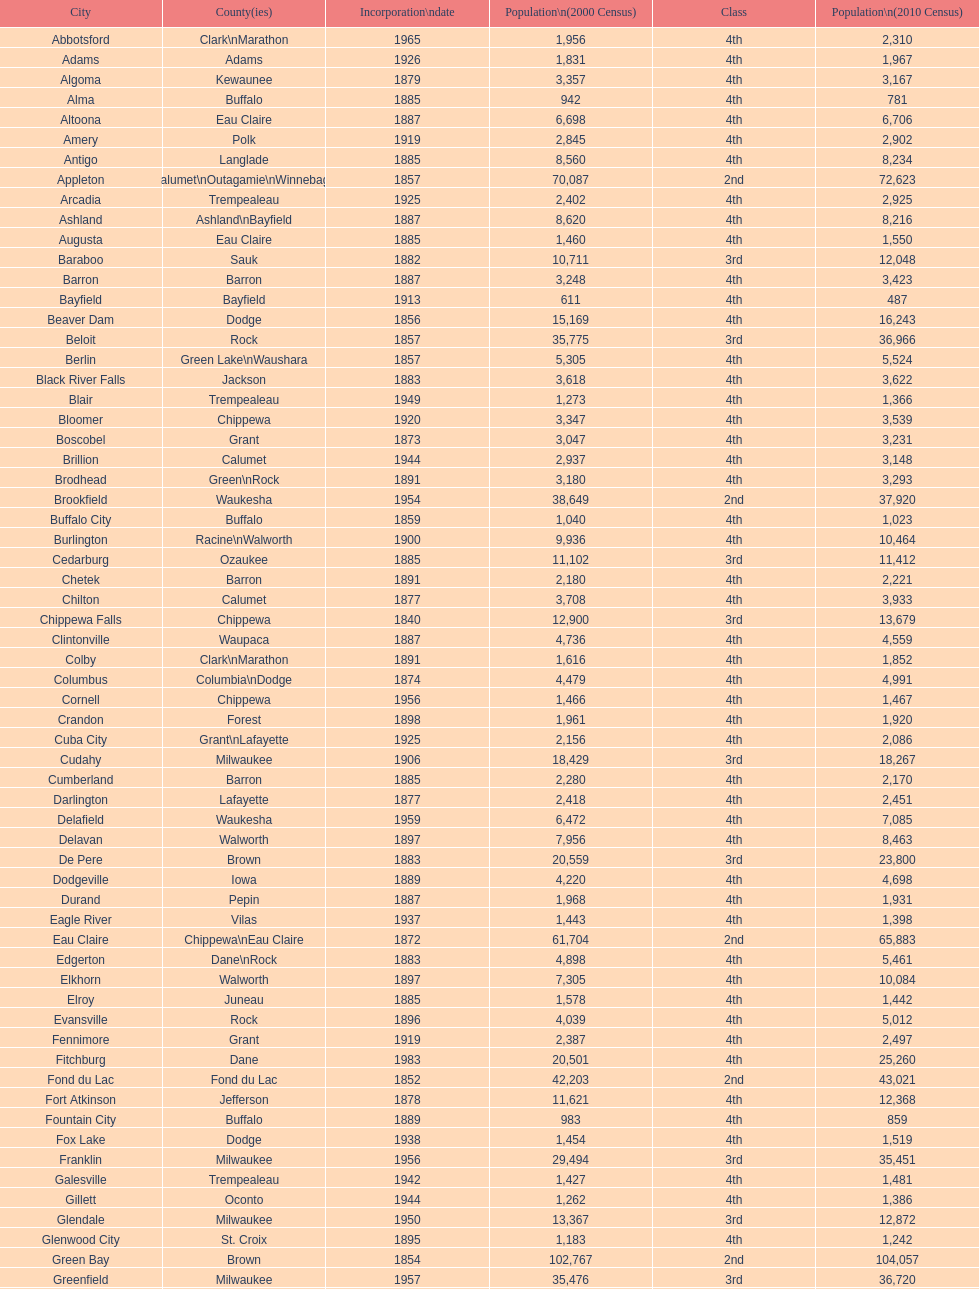What was the first city to be incorporated into wisconsin? Chippewa Falls. 